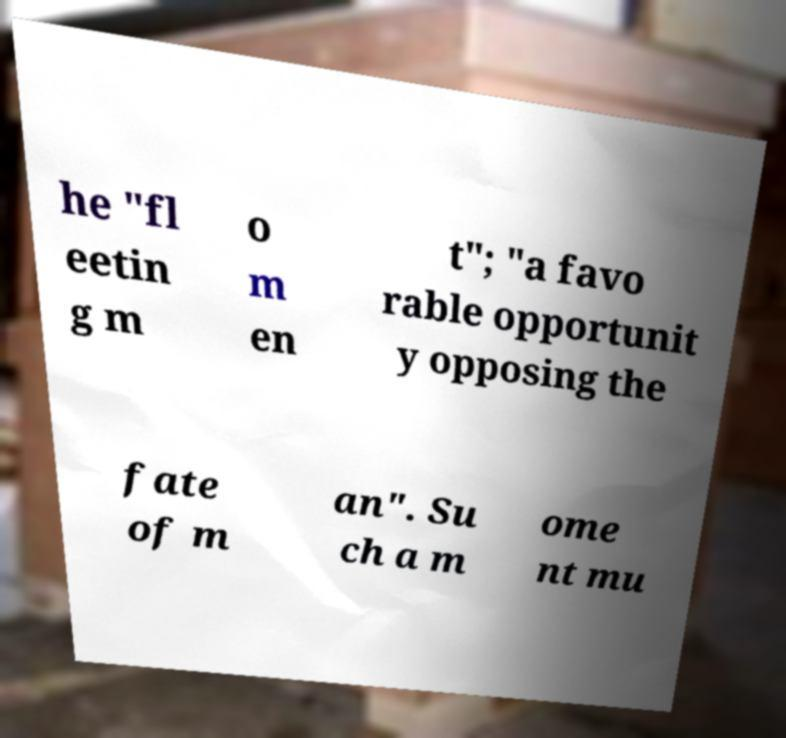Could you assist in decoding the text presented in this image and type it out clearly? he "fl eetin g m o m en t"; "a favo rable opportunit y opposing the fate of m an". Su ch a m ome nt mu 